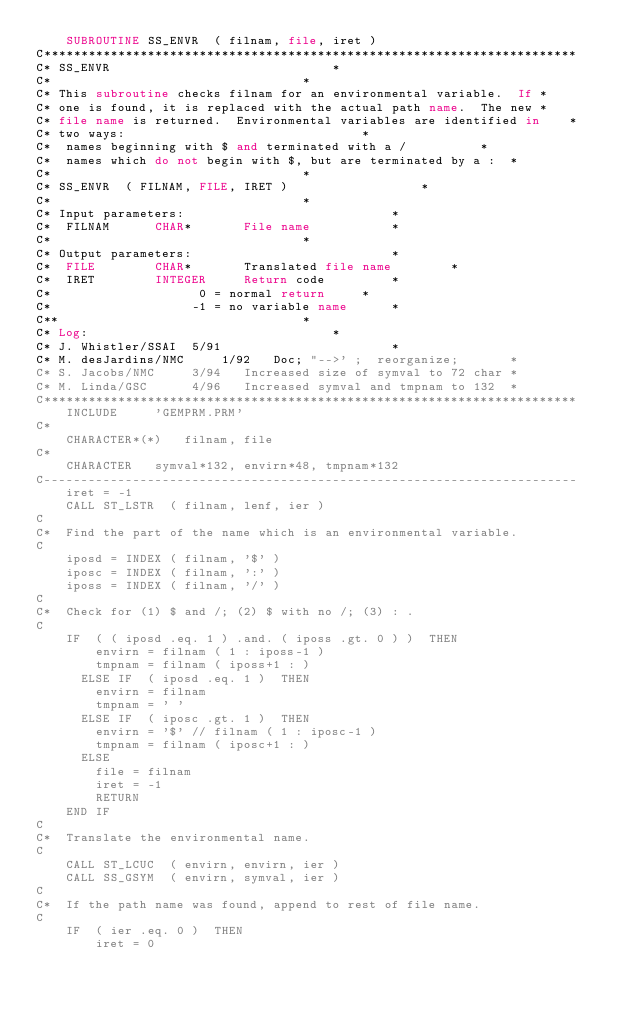Convert code to text. <code><loc_0><loc_0><loc_500><loc_500><_FORTRAN_>	SUBROUTINE SS_ENVR  ( filnam, file, iret )
C************************************************************************
C* SS_ENVR								*
C* 									*
C* This subroutine checks filnam for an environmental variable.  If	*
C* one is found, it is replaced with the actual path name.  The new	*
C* file name is returned.  Environmental variables are identified in	*
C* two ways:								*
C*	names beginning with $ and terminated with a /			*
C*	names which do not begin with $, but are terminated by a :	*
C*									*
C* SS_ENVR  ( FILNAM, FILE, IRET )					*
C* 									*
C* Input parameters:							*
C*	FILNAM		CHAR*		File name 			*
C* 									*
C* Output parameters:							*
C*	FILE		CHAR*		Translated file name		*
C*	IRET		INTEGER		Return code			*
C*					  0 = normal return		*
C*					 -1 = no variable name		*
C**									*
C* Log:									*
C* J. Whistler/SSAI	 5/91						*
C* M. desJardins/NMC	 1/92	Doc; "-->' ;  reorganize;		*
C* S. Jacobs/NMC	 3/94	Increased size of symval to 72 char	*
C* M. Linda/GSC		 4/96	Increased symval and tmpnam to 132	*
C************************************************************************
	INCLUDE		'GEMPRM.PRM'
C*
	CHARACTER*(*)	filnam, file
C*
	CHARACTER	symval*132, envirn*48, tmpnam*132
C------------------------------------------------------------------------
	iret = -1
	CALL ST_LSTR  ( filnam, lenf, ier )
C
C*	Find the part of the name which is an environmental variable.
C
	iposd = INDEX ( filnam, '$' )
	iposc = INDEX ( filnam, ':' )
	iposs = INDEX ( filnam, '/' )
C
C*	Check for (1) $ and /; (2) $ with no /; (3) : .
C
	IF  ( ( iposd .eq. 1 ) .and. ( iposs .gt. 0 ) )  THEN
	    envirn = filnam ( 1 : iposs-1 )
	    tmpnam = filnam ( iposs+1 : )
	  ELSE IF  ( iposd .eq. 1 )  THEN
	    envirn = filnam
	    tmpnam = ' '
	  ELSE IF  ( iposc .gt. 1 )  THEN
	    envirn = '$' // filnam ( 1 : iposc-1 )
	    tmpnam = filnam ( iposc+1 : )
	  ELSE
	    file = filnam
	    iret = -1
	    RETURN
	END IF
C
C*	Translate the environmental name.
C
	CALL ST_LCUC  ( envirn, envirn, ier )
	CALL SS_GSYM  ( envirn, symval, ier )
C
C*	If the path name was found, append to rest of file name.
C
	IF  ( ier .eq. 0 )  THEN
	    iret = 0</code> 